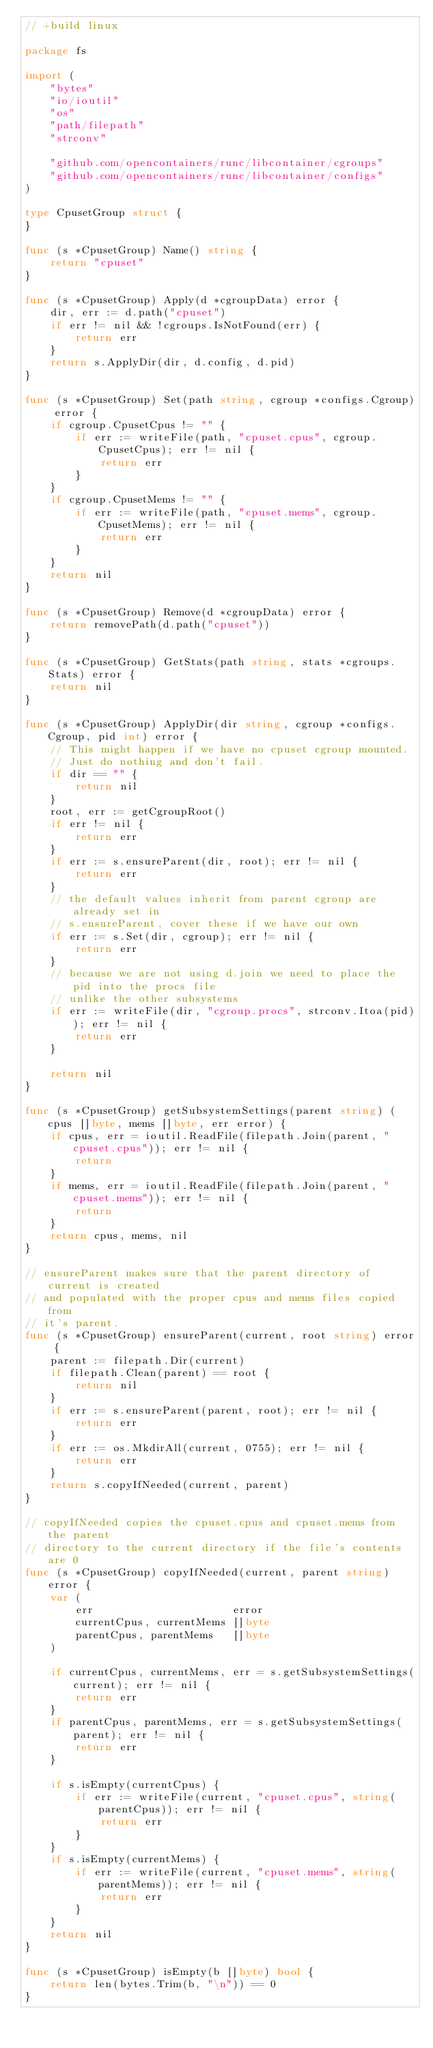Convert code to text. <code><loc_0><loc_0><loc_500><loc_500><_Go_>// +build linux

package fs

import (
	"bytes"
	"io/ioutil"
	"os"
	"path/filepath"
	"strconv"

	"github.com/opencontainers/runc/libcontainer/cgroups"
	"github.com/opencontainers/runc/libcontainer/configs"
)

type CpusetGroup struct {
}

func (s *CpusetGroup) Name() string {
	return "cpuset"
}

func (s *CpusetGroup) Apply(d *cgroupData) error {
	dir, err := d.path("cpuset")
	if err != nil && !cgroups.IsNotFound(err) {
		return err
	}
	return s.ApplyDir(dir, d.config, d.pid)
}

func (s *CpusetGroup) Set(path string, cgroup *configs.Cgroup) error {
	if cgroup.CpusetCpus != "" {
		if err := writeFile(path, "cpuset.cpus", cgroup.CpusetCpus); err != nil {
			return err
		}
	}
	if cgroup.CpusetMems != "" {
		if err := writeFile(path, "cpuset.mems", cgroup.CpusetMems); err != nil {
			return err
		}
	}
	return nil
}

func (s *CpusetGroup) Remove(d *cgroupData) error {
	return removePath(d.path("cpuset"))
}

func (s *CpusetGroup) GetStats(path string, stats *cgroups.Stats) error {
	return nil
}

func (s *CpusetGroup) ApplyDir(dir string, cgroup *configs.Cgroup, pid int) error {
	// This might happen if we have no cpuset cgroup mounted.
	// Just do nothing and don't fail.
	if dir == "" {
		return nil
	}
	root, err := getCgroupRoot()
	if err != nil {
		return err
	}
	if err := s.ensureParent(dir, root); err != nil {
		return err
	}
	// the default values inherit from parent cgroup are already set in
	// s.ensureParent, cover these if we have our own
	if err := s.Set(dir, cgroup); err != nil {
		return err
	}
	// because we are not using d.join we need to place the pid into the procs file
	// unlike the other subsystems
	if err := writeFile(dir, "cgroup.procs", strconv.Itoa(pid)); err != nil {
		return err
	}

	return nil
}

func (s *CpusetGroup) getSubsystemSettings(parent string) (cpus []byte, mems []byte, err error) {
	if cpus, err = ioutil.ReadFile(filepath.Join(parent, "cpuset.cpus")); err != nil {
		return
	}
	if mems, err = ioutil.ReadFile(filepath.Join(parent, "cpuset.mems")); err != nil {
		return
	}
	return cpus, mems, nil
}

// ensureParent makes sure that the parent directory of current is created
// and populated with the proper cpus and mems files copied from
// it's parent.
func (s *CpusetGroup) ensureParent(current, root string) error {
	parent := filepath.Dir(current)
	if filepath.Clean(parent) == root {
		return nil
	}
	if err := s.ensureParent(parent, root); err != nil {
		return err
	}
	if err := os.MkdirAll(current, 0755); err != nil {
		return err
	}
	return s.copyIfNeeded(current, parent)
}

// copyIfNeeded copies the cpuset.cpus and cpuset.mems from the parent
// directory to the current directory if the file's contents are 0
func (s *CpusetGroup) copyIfNeeded(current, parent string) error {
	var (
		err                      error
		currentCpus, currentMems []byte
		parentCpus, parentMems   []byte
	)

	if currentCpus, currentMems, err = s.getSubsystemSettings(current); err != nil {
		return err
	}
	if parentCpus, parentMems, err = s.getSubsystemSettings(parent); err != nil {
		return err
	}

	if s.isEmpty(currentCpus) {
		if err := writeFile(current, "cpuset.cpus", string(parentCpus)); err != nil {
			return err
		}
	}
	if s.isEmpty(currentMems) {
		if err := writeFile(current, "cpuset.mems", string(parentMems)); err != nil {
			return err
		}
	}
	return nil
}

func (s *CpusetGroup) isEmpty(b []byte) bool {
	return len(bytes.Trim(b, "\n")) == 0
}
</code> 